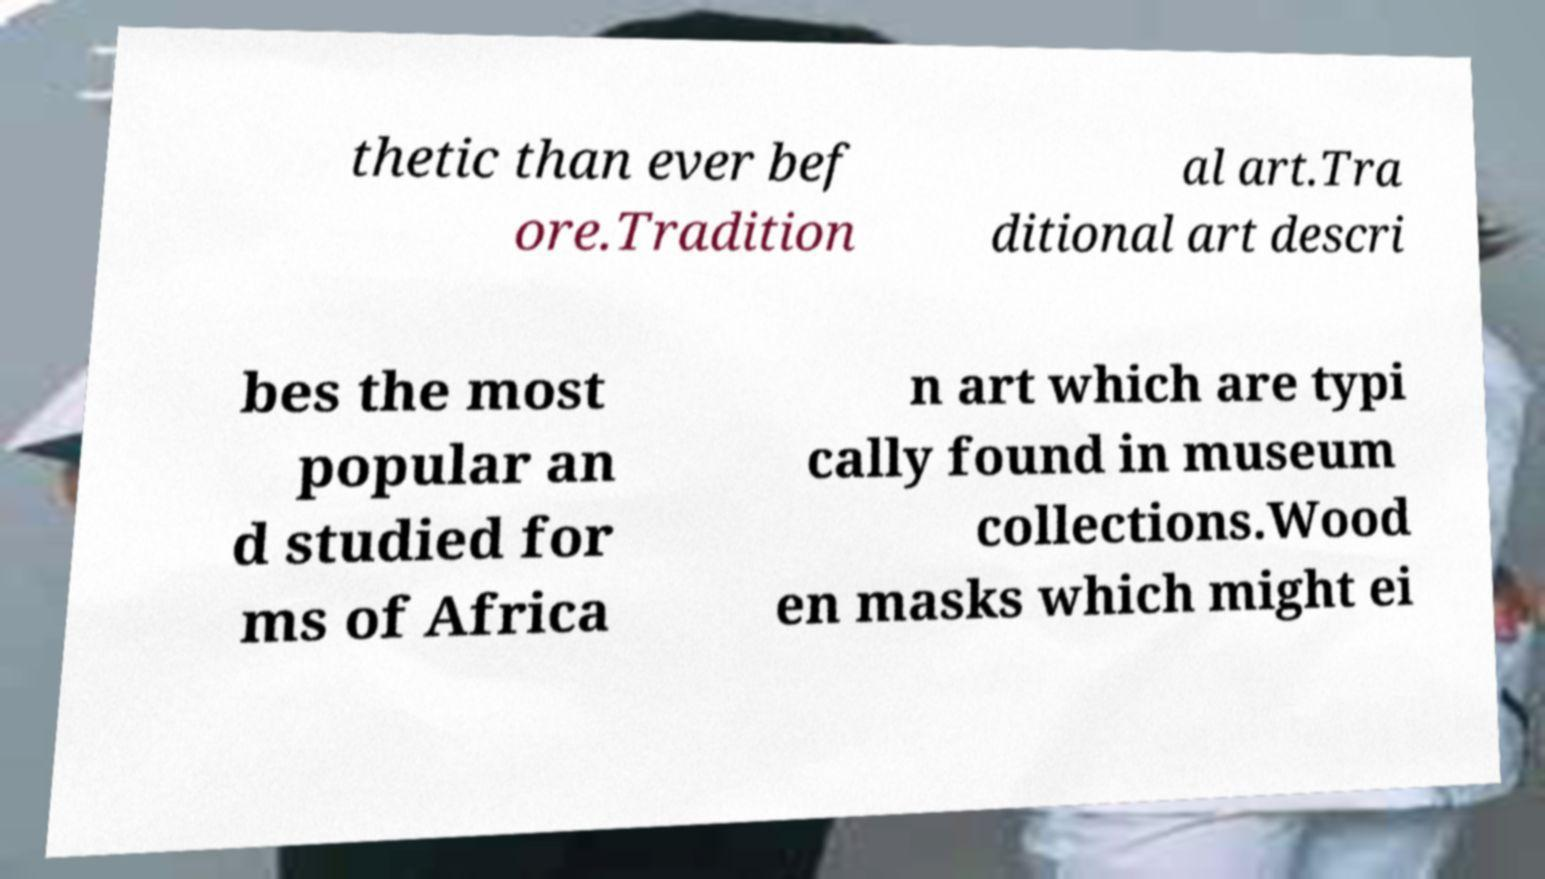Please identify and transcribe the text found in this image. thetic than ever bef ore.Tradition al art.Tra ditional art descri bes the most popular an d studied for ms of Africa n art which are typi cally found in museum collections.Wood en masks which might ei 